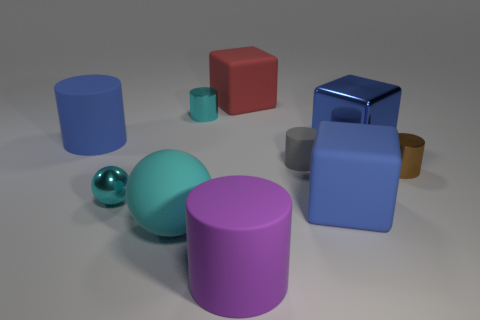Subtract all blue cylinders. How many cylinders are left? 4 Subtract all small gray cylinders. How many cylinders are left? 4 Subtract all green cylinders. Subtract all green blocks. How many cylinders are left? 5 Subtract all spheres. How many objects are left? 8 Add 6 cyan rubber balls. How many cyan rubber balls are left? 7 Add 1 green spheres. How many green spheres exist? 1 Subtract 0 yellow cylinders. How many objects are left? 10 Subtract all big purple cylinders. Subtract all big objects. How many objects are left? 3 